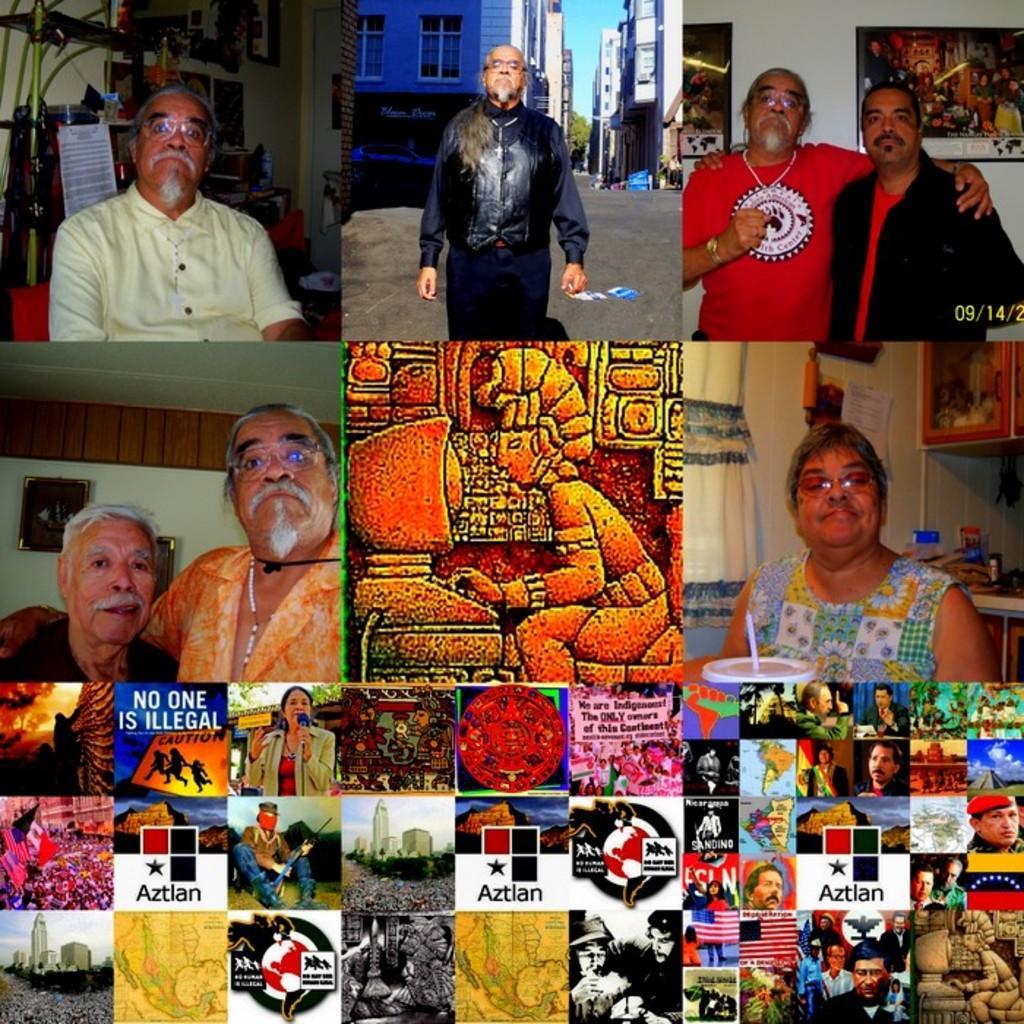Describe this image in one or two sentences. In this picture I can see collage of nine images. In some of the images I can see humans. In one picture I can see a carving on the wall. In some pictures there are few logos. 